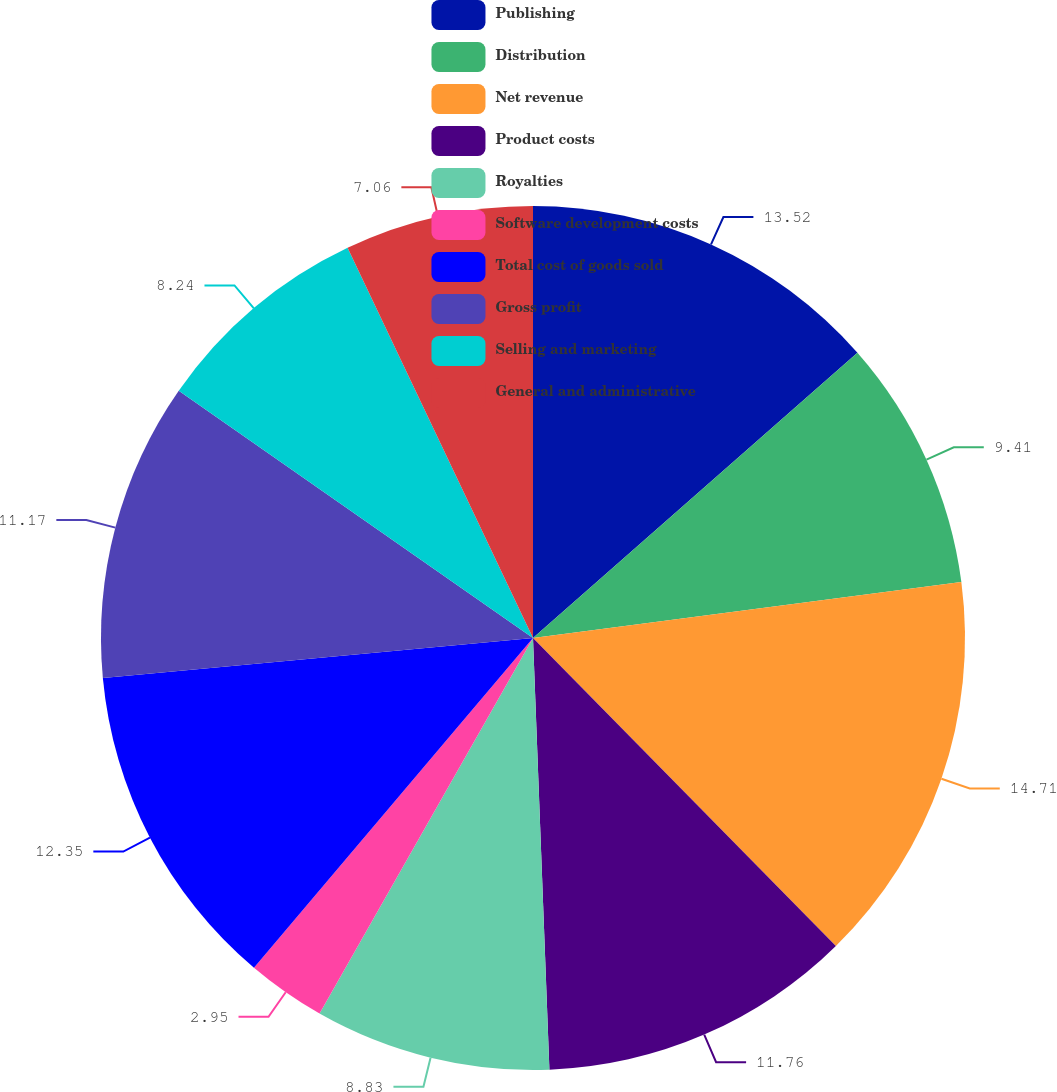Convert chart. <chart><loc_0><loc_0><loc_500><loc_500><pie_chart><fcel>Publishing<fcel>Distribution<fcel>Net revenue<fcel>Product costs<fcel>Royalties<fcel>Software development costs<fcel>Total cost of goods sold<fcel>Gross profit<fcel>Selling and marketing<fcel>General and administrative<nl><fcel>13.52%<fcel>9.41%<fcel>14.7%<fcel>11.76%<fcel>8.83%<fcel>2.95%<fcel>12.35%<fcel>11.17%<fcel>8.24%<fcel>7.06%<nl></chart> 